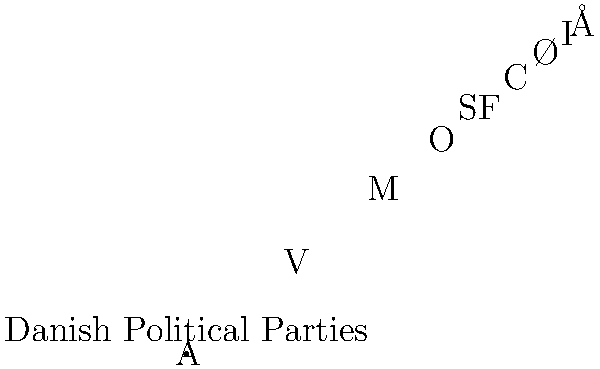A pie chart representing the distribution of seats in the Danish Parliament is rotated 120° counterclockwise. If the "A" party (red sector) was originally at the top of the chart, which party will now be closest to the top after rotation? To solve this problem, we need to follow these steps:

1. Understand the initial position: The "A" party (red sector) is at the top of the chart.

2. Visualize the rotation: The chart is rotated 120° counterclockwise.

3. Analyze the pie chart:
   - The chart is divided into 9 sectors, each representing a political party.
   - The parties are arranged clockwise in the order: A, V, M, O, SF, C, Ø, I, Å.

4. Calculate the new position:
   - A 120° counterclockwise rotation is equivalent to moving 4 sectors clockwise.
   - Starting from A and moving 4 sectors clockwise, we get: A → V → M → O → SF.

5. Conclude: After the 120° counterclockwise rotation, the SF party (light purple sector) will be closest to the top of the chart.
Answer: SF 